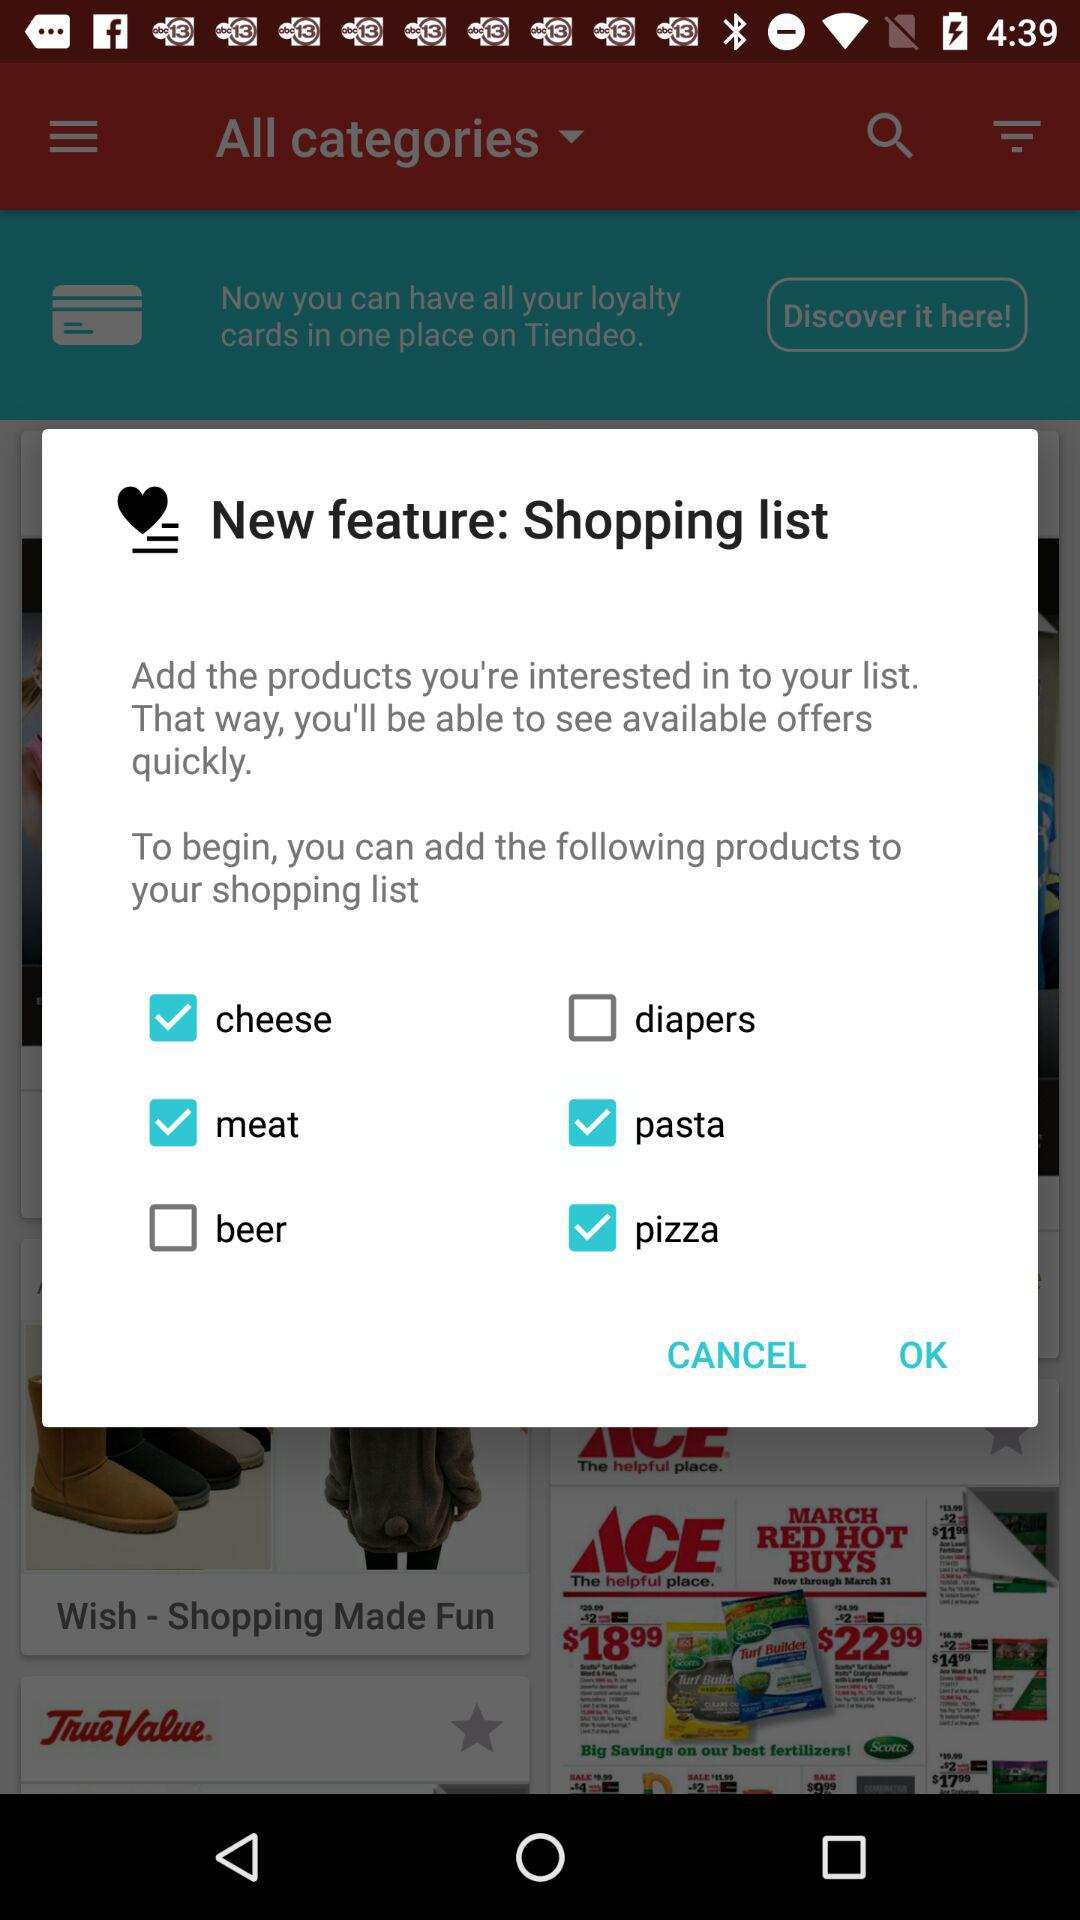Which products are added to the shopping list? The products added to the shopping list are "cheese", "meat", "pasta" and "pizza". 